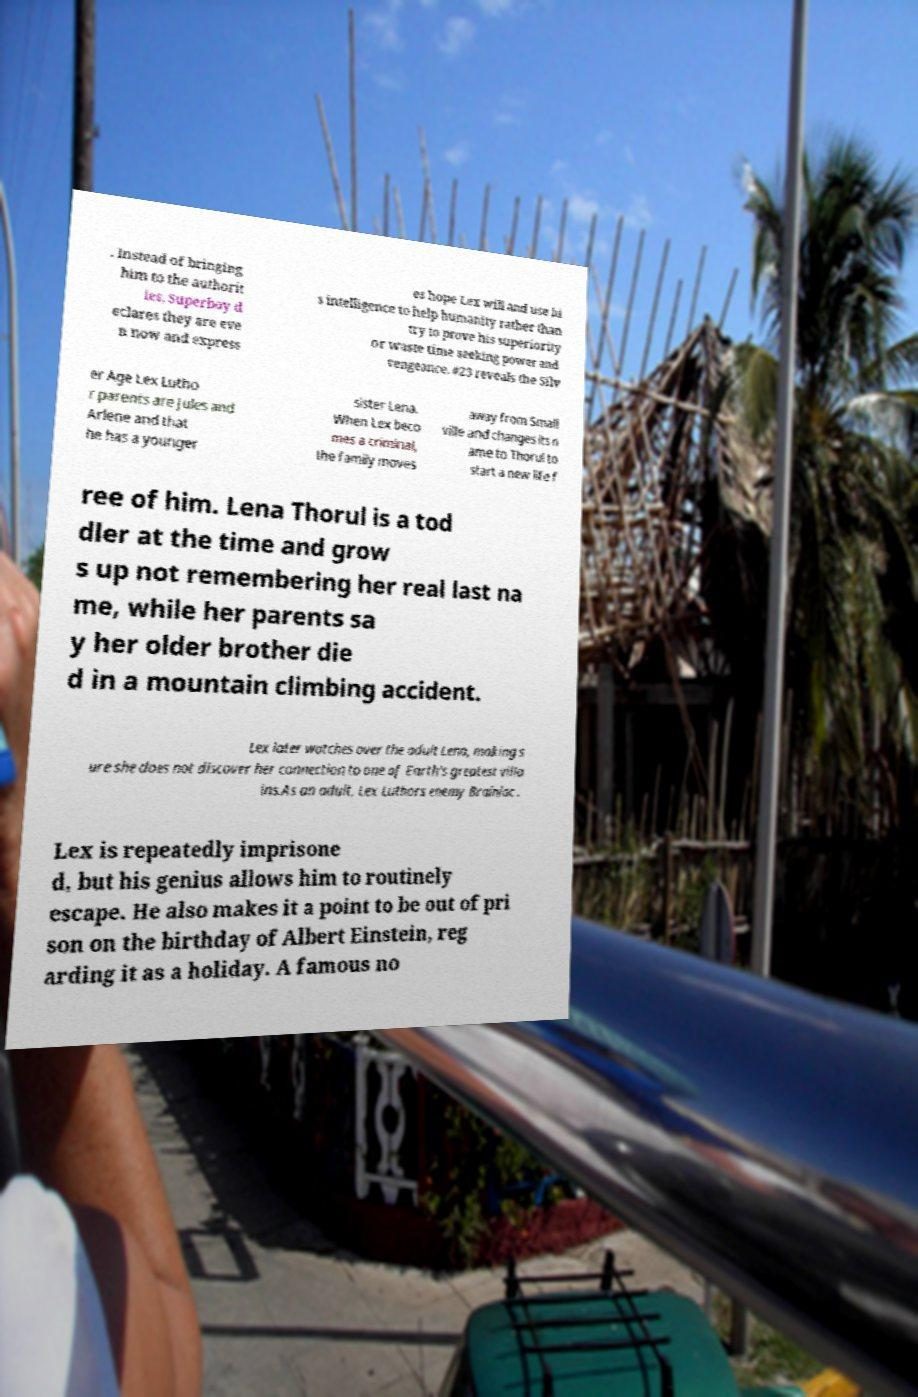What messages or text are displayed in this image? I need them in a readable, typed format. . Instead of bringing him to the authorit ies, Superboy d eclares they are eve n now and express es hope Lex will and use hi s intelligence to help humanity rather than try to prove his superiority or waste time seeking power and vengeance. #23 reveals the Silv er Age Lex Lutho r parents are Jules and Arlene and that he has a younger sister Lena. When Lex beco mes a criminal, the family moves away from Small ville and changes its n ame to Thorul to start a new life f ree of him. Lena Thorul is a tod dler at the time and grow s up not remembering her real last na me, while her parents sa y her older brother die d in a mountain climbing accident. Lex later watches over the adult Lena, making s ure she does not discover her connection to one of Earth's greatest villa ins.As an adult, Lex Luthors enemy Brainiac . Lex is repeatedly imprisone d, but his genius allows him to routinely escape. He also makes it a point to be out of pri son on the birthday of Albert Einstein, reg arding it as a holiday. A famous no 